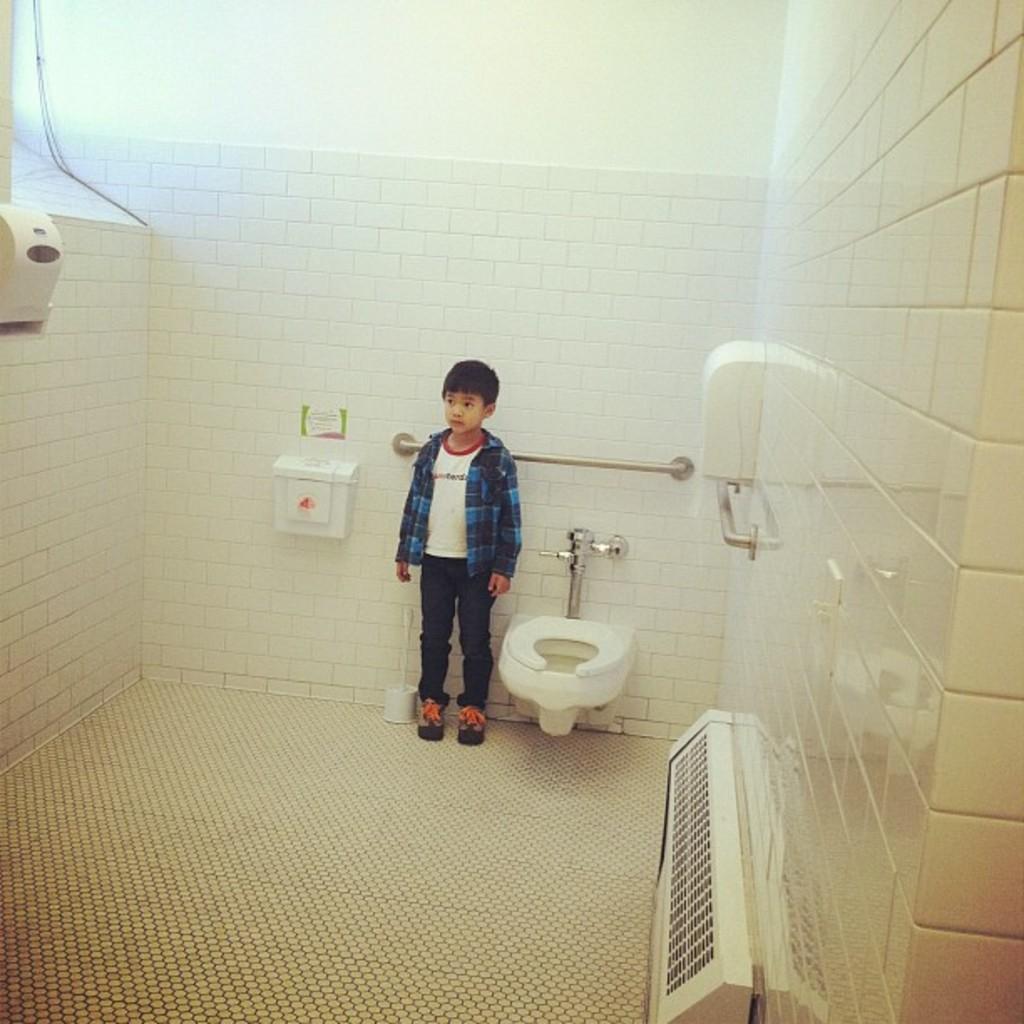Please provide a concise description of this image. In the center of the image there is a boy standing on the floor. On the right side of the image we can see tissue dispenser, toilet and tap. On the left side of the image we can see tissues, dustbin. In the background there is wall. 